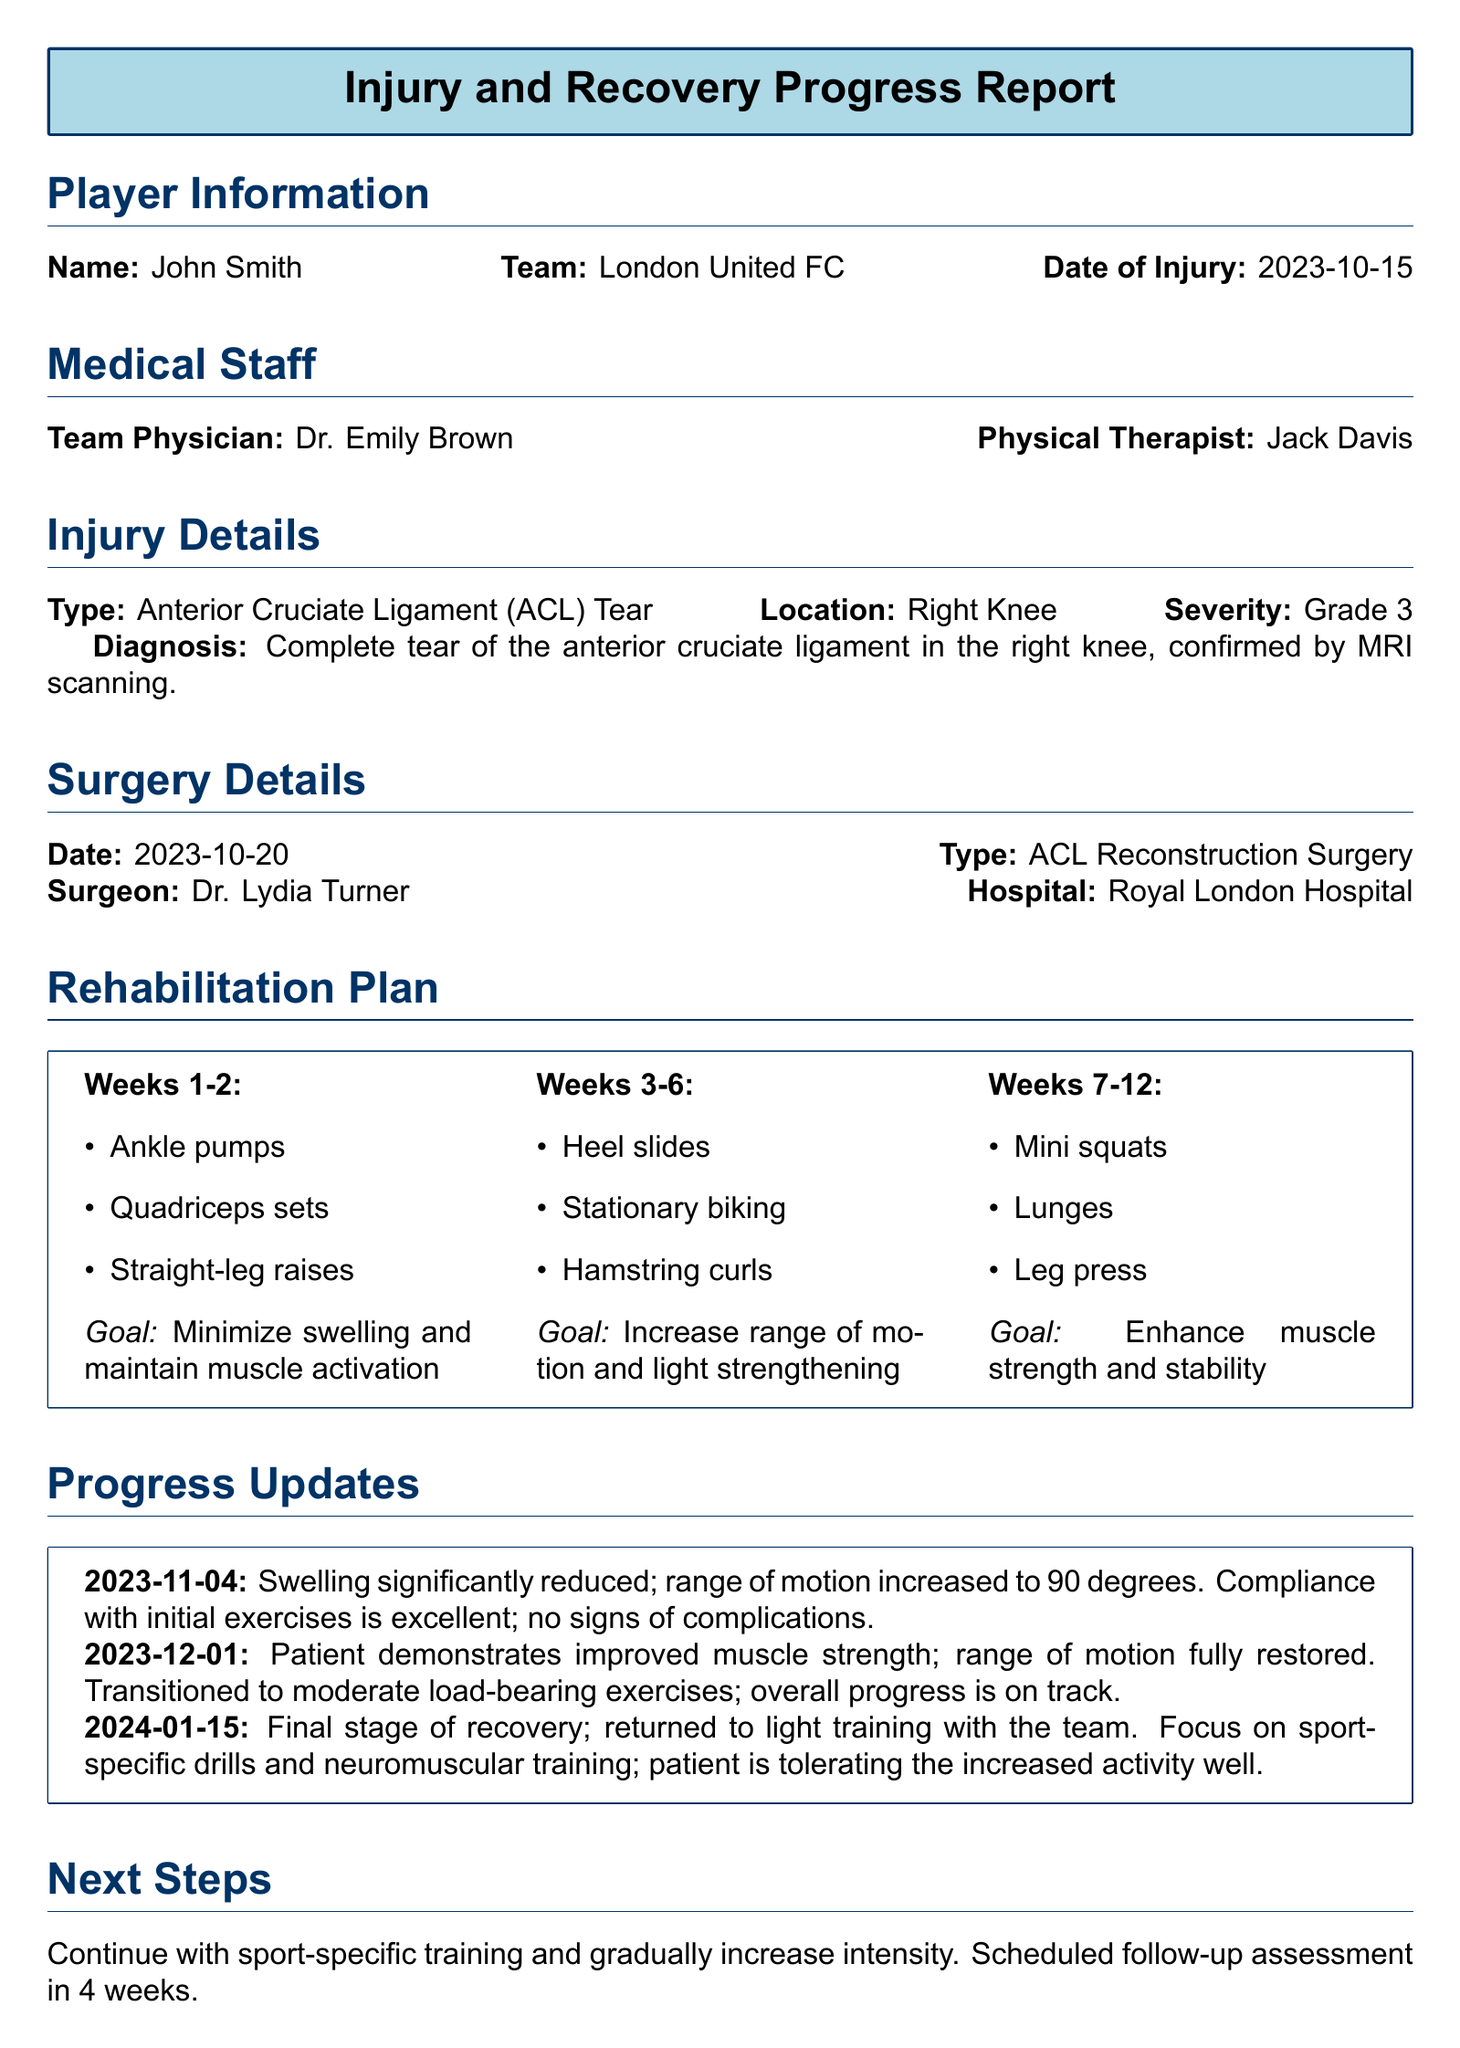What is the player's name? The player's name is provided in the Player Information section of the document.
Answer: John Smith What is the date of injury? The date of injury is listed in the Player Information section.
Answer: 2023-10-15 What type of injury did the player sustain? The type of injury is detailed in the Injury Details section.
Answer: Anterior Cruciate Ligament (ACL) Tear What was the severity of the injury? The severity of the injury is specified in the Injury Details section of the report.
Answer: Grade 3 Who is the team physician? The team physician’s name is found in the Medical Staff section.
Answer: Dr. Emily Brown What is the goal for weeks 1-2 of the rehabilitation plan? The goal for the first two weeks is stated within the Rehabilitation Plan.
Answer: Minimize swelling and maintain muscle activation What was the range of motion reported on 2023-11-04? The range of motion is mentioned in the Progress Update for that date.
Answer: 90 degrees When did the patient return to light training? The date of return to light training is provided in the Progress Updates section.
Answer: 2024-01-15 What is the expected timeframe for a full recovery? The timeframe for recovery is indicated in the Remarks section of the document.
Answer: 6 months post-surgery 